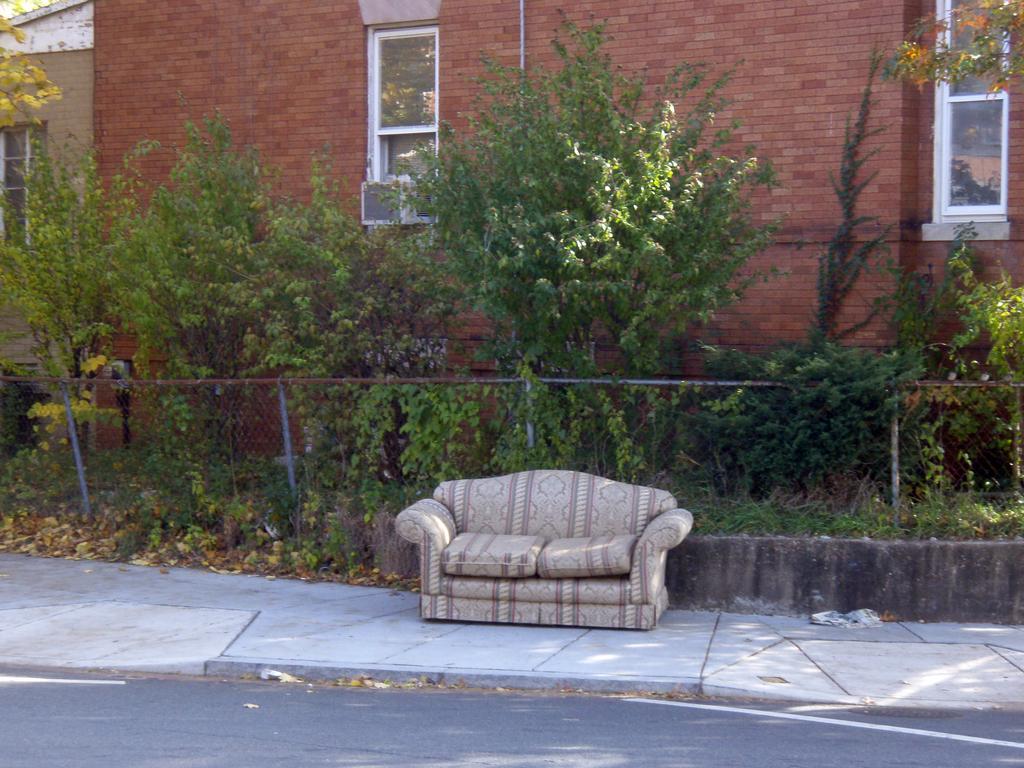Can you describe this image briefly? In this picture we can able to see plants in-front of this building. This building walls are made with bricks and in-front of this plants there is a couch with pillows. This building is with windows. 